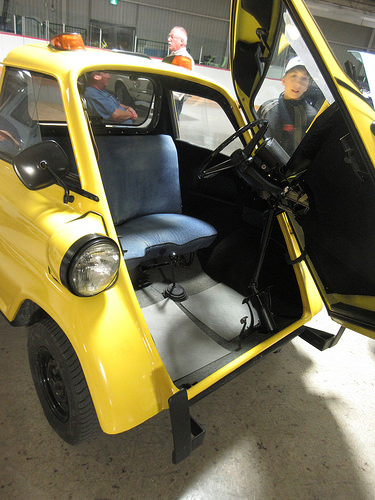<image>
Is the grandpa in front of the carlo? No. The grandpa is not in front of the carlo. The spatial positioning shows a different relationship between these objects. 